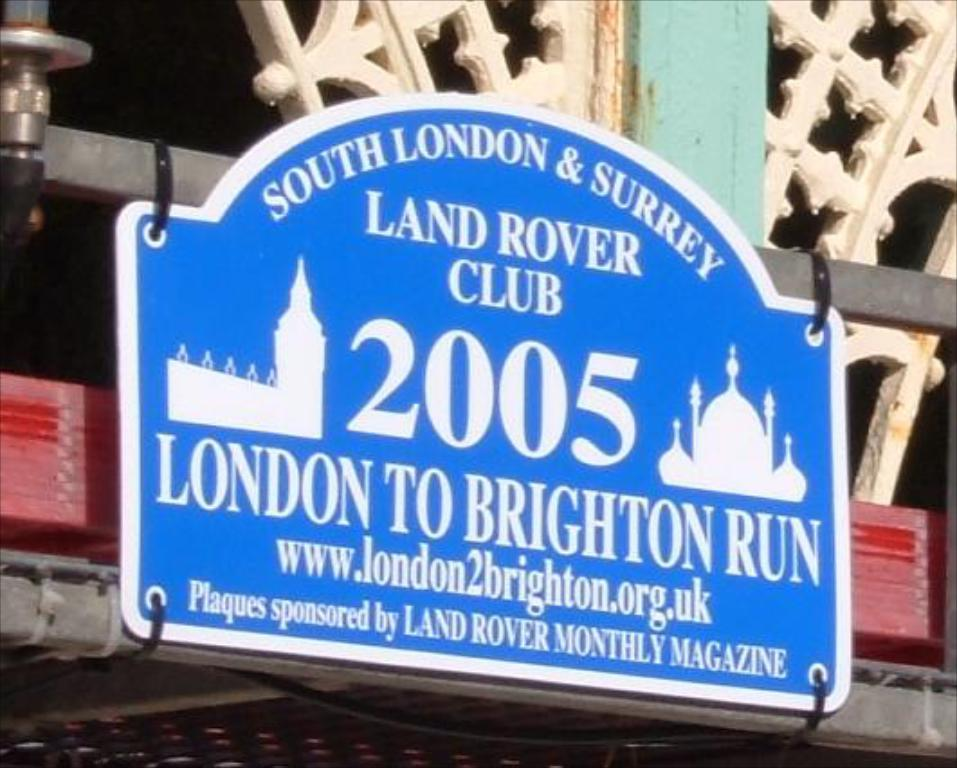<image>
Write a terse but informative summary of the picture. Blue sign hanging on a wall that says "London to Brighton Run". 